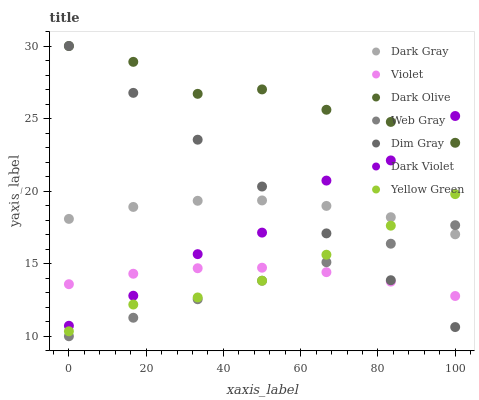Does Web Gray have the minimum area under the curve?
Answer yes or no. Yes. Does Dark Olive have the maximum area under the curve?
Answer yes or no. Yes. Does Yellow Green have the minimum area under the curve?
Answer yes or no. No. Does Yellow Green have the maximum area under the curve?
Answer yes or no. No. Is Dim Gray the smoothest?
Answer yes or no. Yes. Is Dark Violet the roughest?
Answer yes or no. Yes. Is Yellow Green the smoothest?
Answer yes or no. No. Is Yellow Green the roughest?
Answer yes or no. No. Does Web Gray have the lowest value?
Answer yes or no. Yes. Does Yellow Green have the lowest value?
Answer yes or no. No. Does Dark Olive have the highest value?
Answer yes or no. Yes. Does Yellow Green have the highest value?
Answer yes or no. No. Is Violet less than Dark Olive?
Answer yes or no. Yes. Is Dark Olive greater than Dark Gray?
Answer yes or no. Yes. Does Violet intersect Dark Violet?
Answer yes or no. Yes. Is Violet less than Dark Violet?
Answer yes or no. No. Is Violet greater than Dark Violet?
Answer yes or no. No. Does Violet intersect Dark Olive?
Answer yes or no. No. 